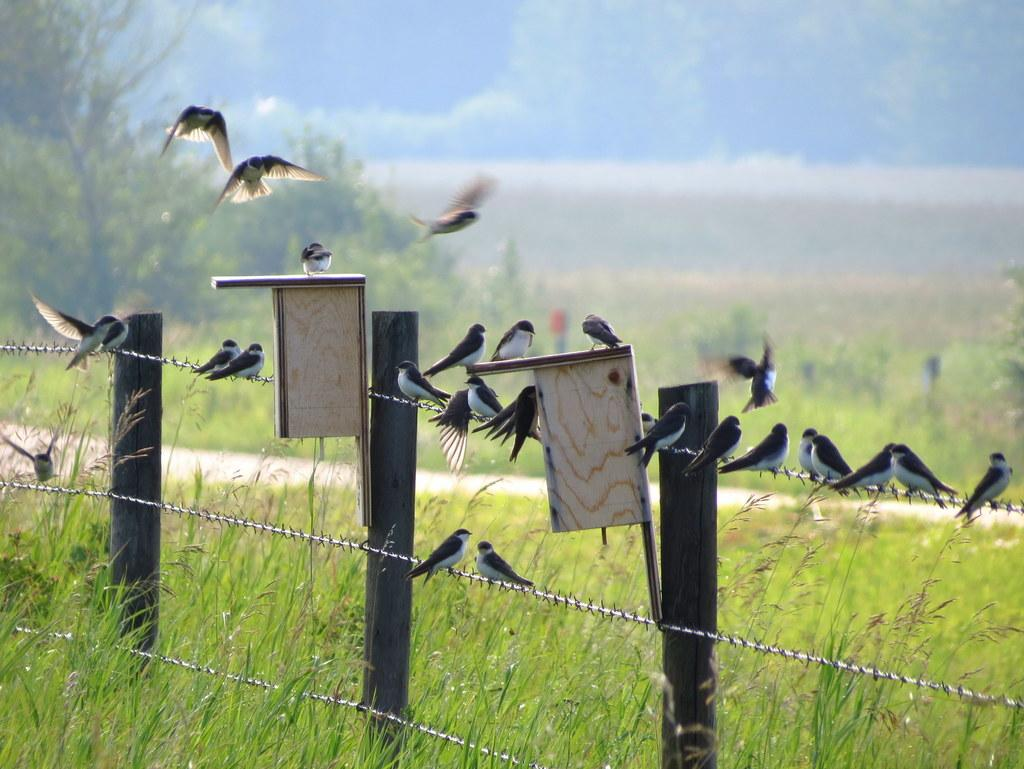What are the birds doing in the image? Some birds are sitting on a bending wire, while two birds are flying in the image. What can be seen in the background of the image? There are places visible in the image. What type of vegetation is present in the image? Green grass and trees are visible in the image. How many lizards can be seen crawling on the stone in the image? There are no lizards or stones present in the image. 